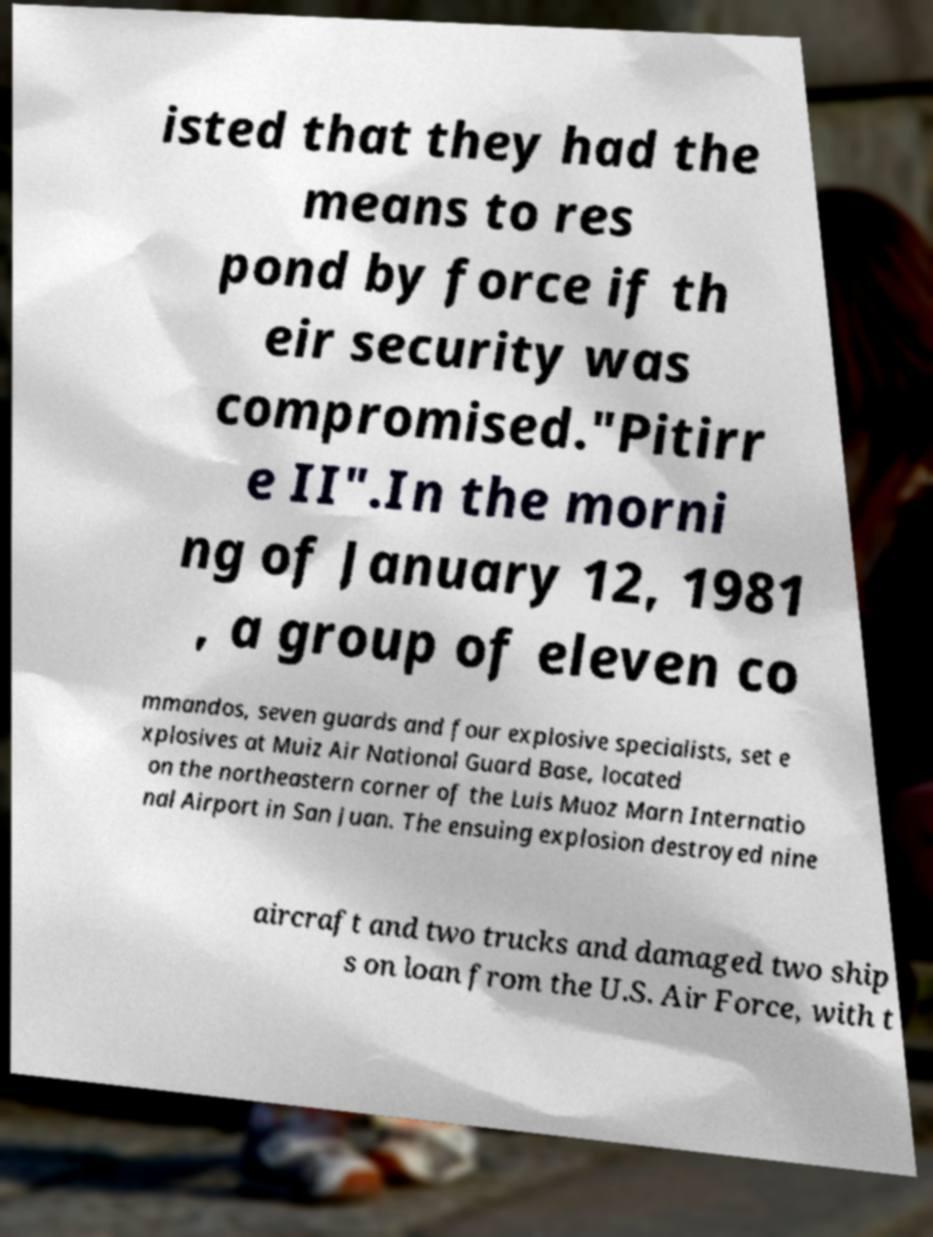Can you read and provide the text displayed in the image?This photo seems to have some interesting text. Can you extract and type it out for me? isted that they had the means to res pond by force if th eir security was compromised."Pitirr e II".In the morni ng of January 12, 1981 , a group of eleven co mmandos, seven guards and four explosive specialists, set e xplosives at Muiz Air National Guard Base, located on the northeastern corner of the Luis Muoz Marn Internatio nal Airport in San Juan. The ensuing explosion destroyed nine aircraft and two trucks and damaged two ship s on loan from the U.S. Air Force, with t 